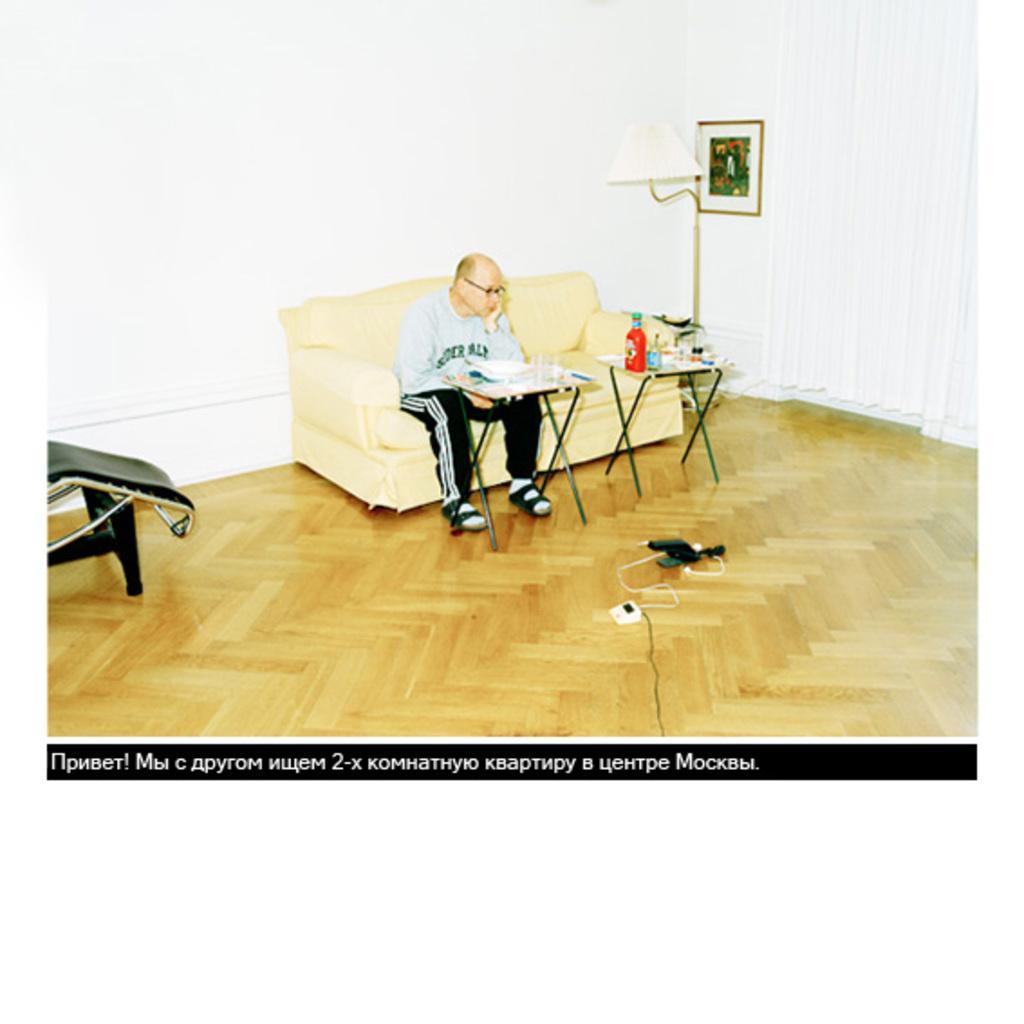Please provide a concise description of this image. In the image a man is sitting on a sofa. In front of him there are two tables. On the tables there are glasses, bottles, and few other things. Beside the sofa there is a lamp and a photo frame hanged on the wall. There are few cables on the floor. On the top right there are curtains. 